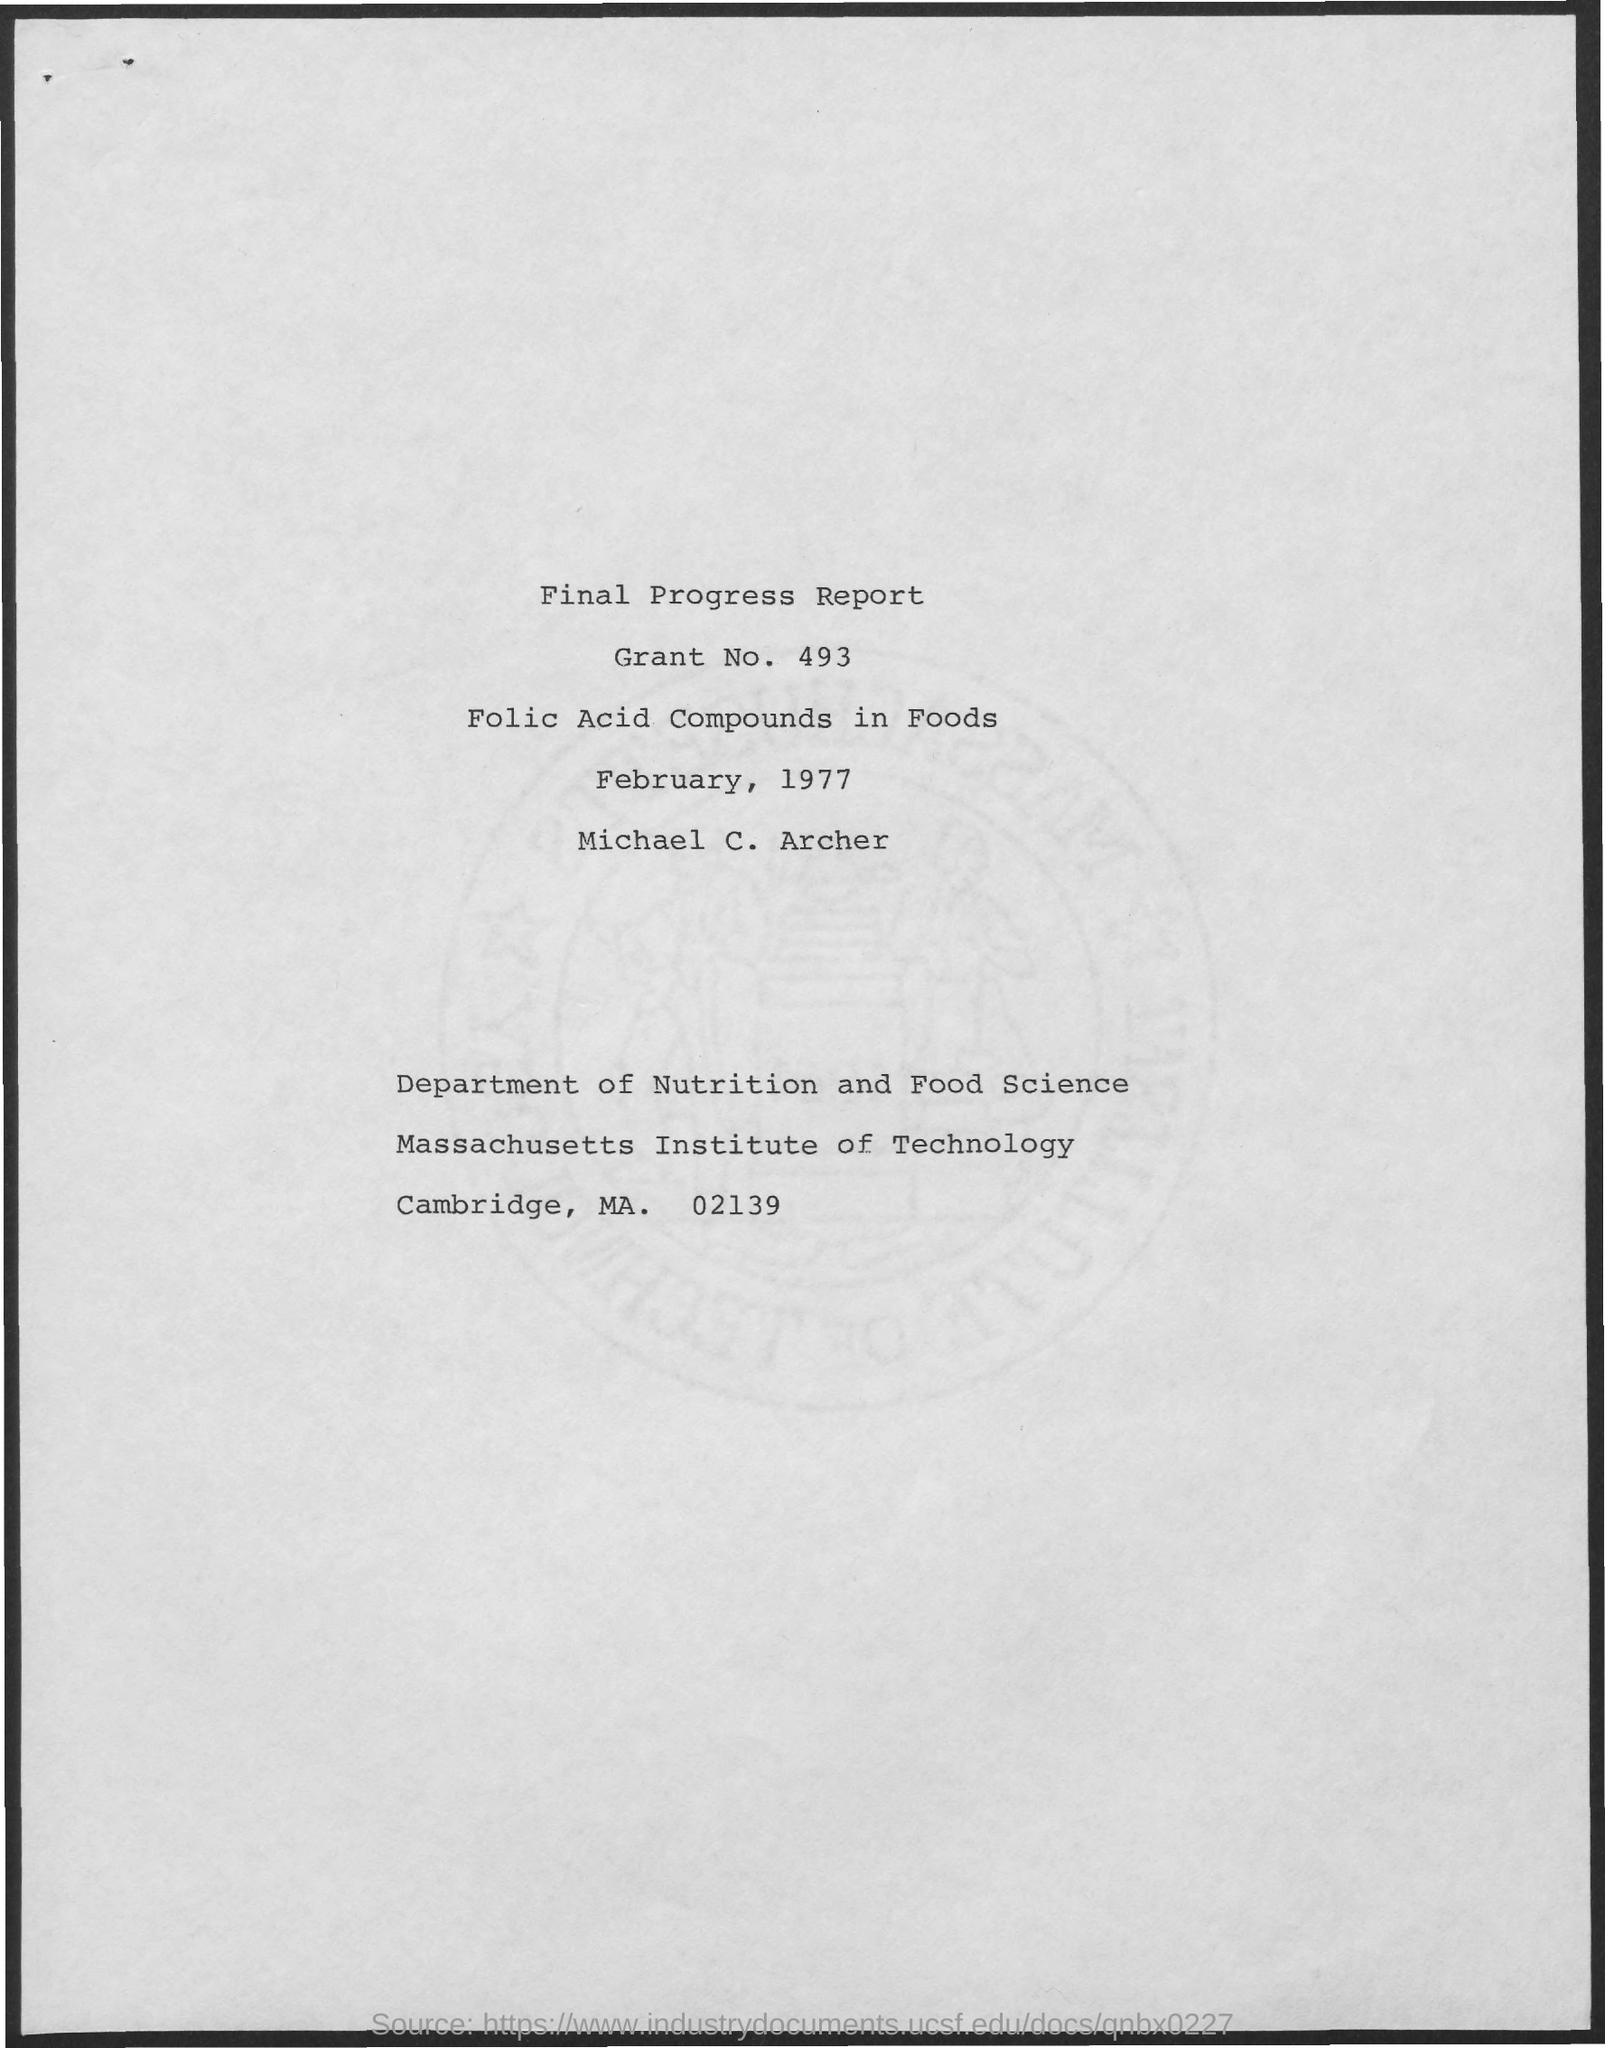Specify some key components in this picture. The Grant No. mentioned in this report is 493. The article title is "Folic Acid Compounds in Foods: What They Are and How They Affect Our Health". The author's name mentioned is Michael C. Archer. The date mentioned in this report is February 1977. 